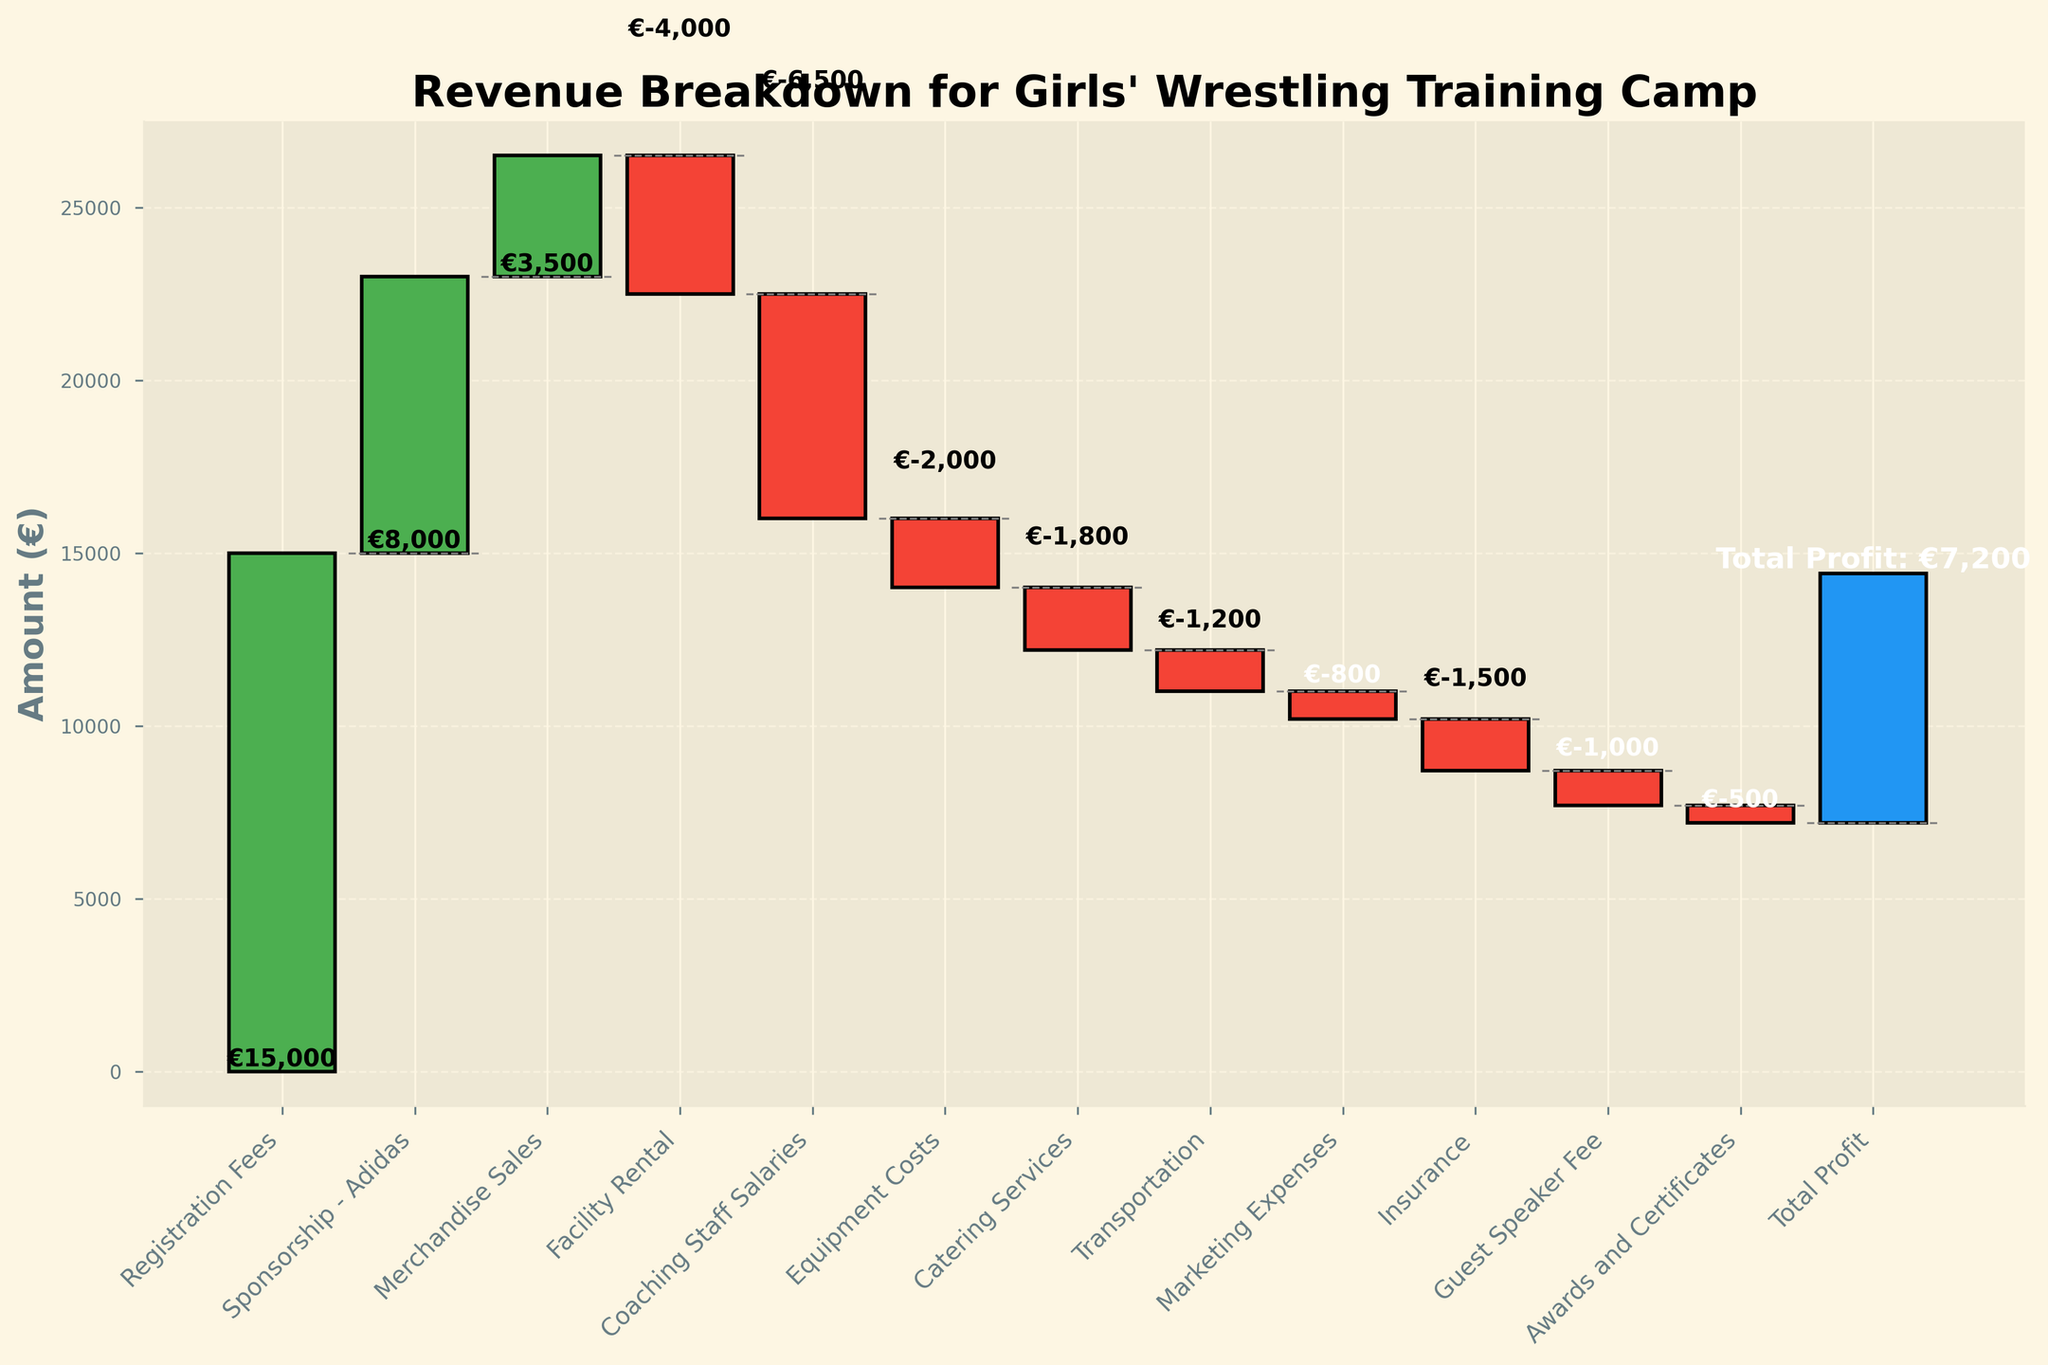How much did the training camp earn from registration fees? The registration fees are represented by one of the bars, showing a value of €15,000.
Answer: €15,000 Which category has the highest expense, and how much is it? The highest expense is represented by the Coaching Staff Salaries bar, which has a negative value of €6,500.
Answer: Coaching Staff Salaries, €6,500 What is the total income from Sponsorship and Merchandise Sales combined? Add the Sponsorship - Adidas (€8,000) and Merchandise Sales (€3,500) together. The sum is €8,000 + €3,500 = €11,500.
Answer: €11,500 Compare the income from registration fees and the total expenses for the camp. Which is higher and by how much? The registration fees are €15,000. Total expenses can be summed up by adding all the negative amounts. Total expenses = -€4,000 (Facility Rental) - €6,500 (Staff Salaries) - €2,000 (Equipment) - €1,800 (Catering) - €1,200 (Transportation) - €800 (Marketing) - €1,500 (Insurance) - €1,000 (Guest Speaker) - €500 (Awards) = -€19,300. The difference is €15,000 - €19,300 = -€4,300, so expenses are higher by €4,300.
Answer: Expenses are higher by €4,300 What color represents the expenses in the chart? The expenses are represented by the bars in red color.
Answer: Red How much profit did the camp make in total? The total profit is shown at the end of the chart, indicated as €7,200.
Answer: €7,200 Identify two smallest expenses and their amounts. The two smallest expenses are Awards and Certificates (€500) and Marketing Expenses (€800).
Answer: Awards (€500), Marketing (€800) What is the combined total cost of Caterings Services and Equipment Costs? Add Catering Services (-€1,800) and Equipment Costs (-€2,000) together. The sum is -€1,800 + (-€2,000) = -€3,800.
Answer: -€3,800 If Sponsorship - Adidas and Merchandise Sales were doubled, how much would the total profit be? Currently, Sponsorship - Adidas is €8,000 and Merchandise Sales is €3,500. If both are doubled: 2*€8,000 + 2*€3,500 = €16,000 + €7,000 = €23,000. The current total profit is €7,200, which includes the current income from these two categories (€8,000 + €3,500 = €11,500). Adding the doubled amounts and subtracting the current amounts gives us €7,200 + €23,000 - €11,500 = €18,700.
Answer: €18,700 